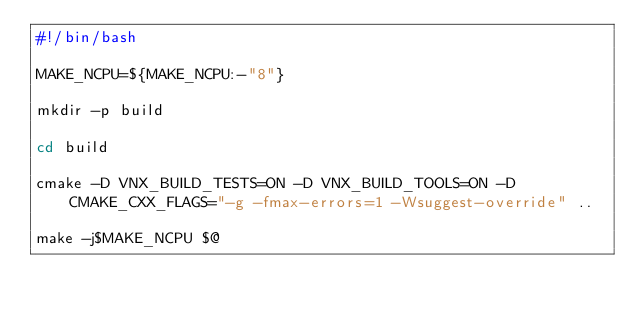<code> <loc_0><loc_0><loc_500><loc_500><_Bash_>#!/bin/bash

MAKE_NCPU=${MAKE_NCPU:-"8"}

mkdir -p build

cd build

cmake -D VNX_BUILD_TESTS=ON -D VNX_BUILD_TOOLS=ON -D CMAKE_CXX_FLAGS="-g -fmax-errors=1 -Wsuggest-override" ..

make -j$MAKE_NCPU $@

</code> 